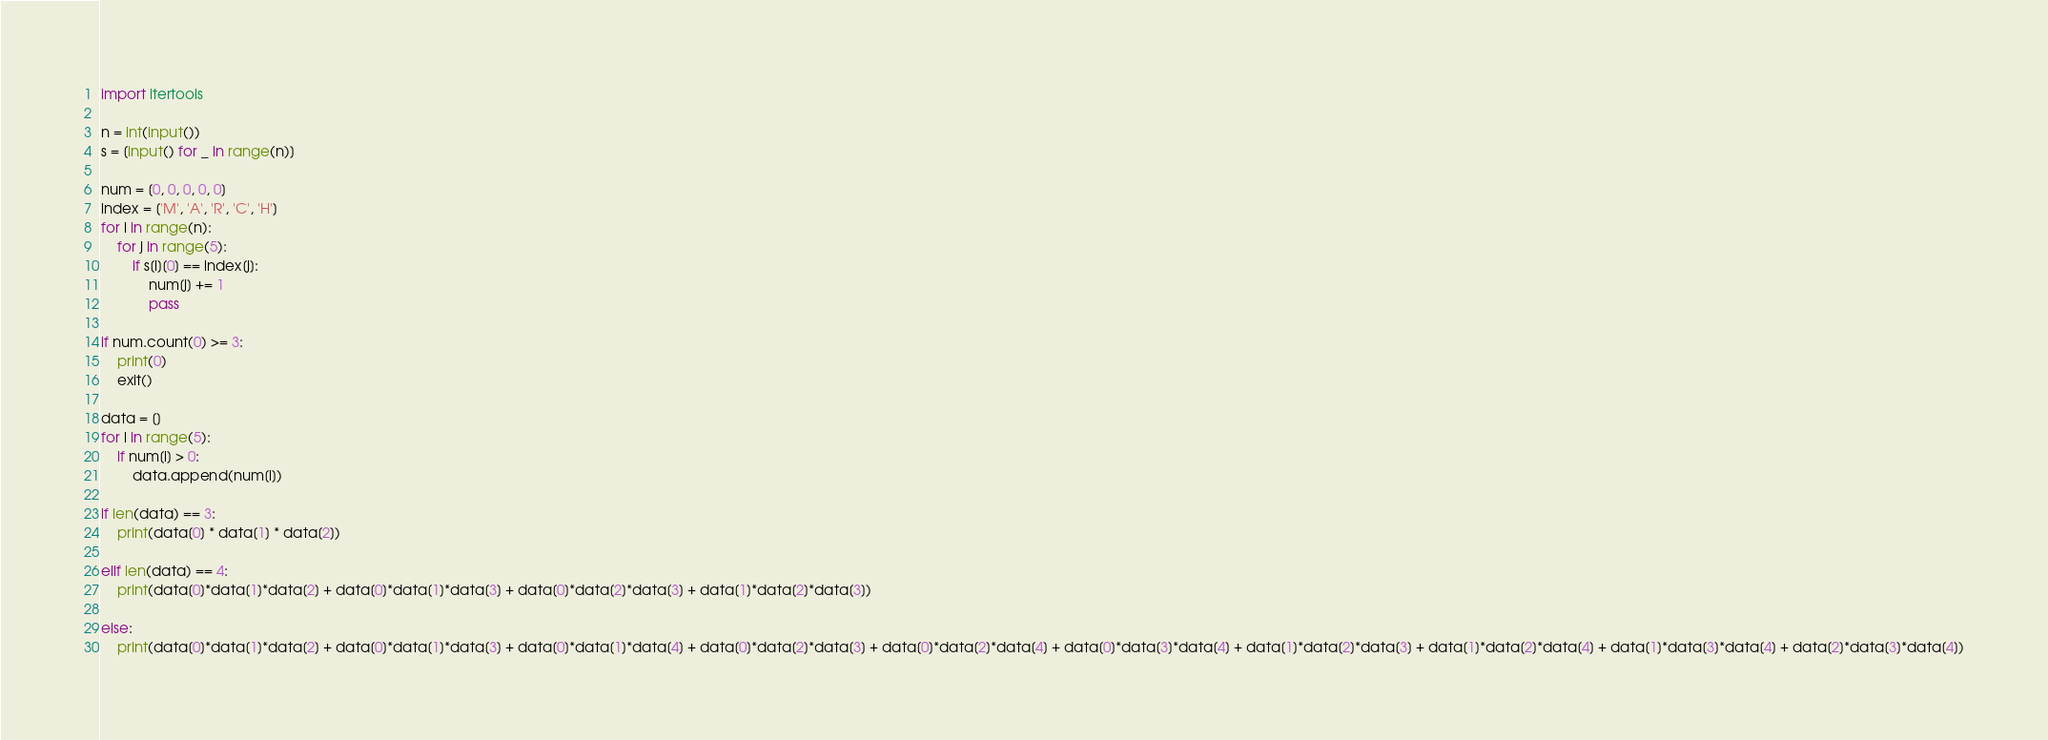Convert code to text. <code><loc_0><loc_0><loc_500><loc_500><_Python_>import itertools

n = int(input())
s = [input() for _ in range(n)]

num = [0, 0, 0, 0, 0]
index = ['M', 'A', 'R', 'C', 'H']
for i in range(n):
    for j in range(5):
        if s[i][0] == index[j]:
            num[j] += 1
            pass

if num.count(0) >= 3:
    print(0)
    exit()

data = []
for i in range(5):
    if num[i] > 0:
        data.append(num[i])

if len(data) == 3:
    print(data[0] * data[1] * data[2])

elif len(data) == 4:
    print(data[0]*data[1]*data[2] + data[0]*data[1]*data[3] + data[0]*data[2]*data[3] + data[1]*data[2]*data[3])

else:
    print(data[0]*data[1]*data[2] + data[0]*data[1]*data[3] + data[0]*data[1]*data[4] + data[0]*data[2]*data[3] + data[0]*data[2]*data[4] + data[0]*data[3]*data[4] + data[1]*data[2]*data[3] + data[1]*data[2]*data[4] + data[1]*data[3]*data[4] + data[2]*data[3]*data[4])</code> 